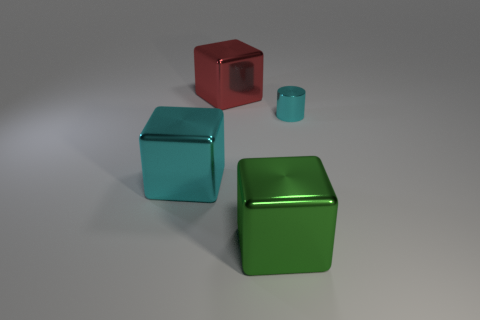Are there an equal number of tiny cylinders left of the cyan metal block and red metallic cubes that are right of the red shiny cube? After closely examining the image, I can confirm that the number of tiny cylinders located to the left of the cyan metal block is equal to the number of red metallic cubes situated to the right of the red shiny cube. 